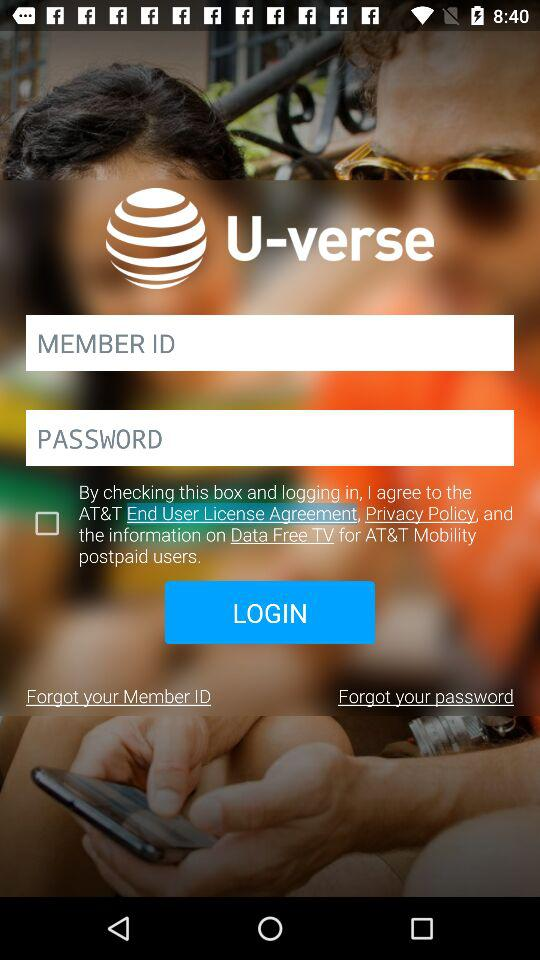Is" By checking this box and logging in" checked or unchecked?
Answer the question using a single word or phrase. It is unchecked. 